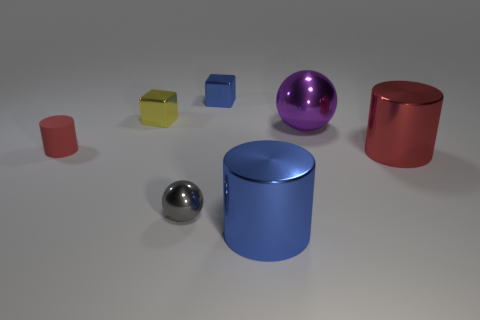Is there anything else that is the same material as the small cylinder?
Keep it short and to the point. No. Are there any small blue matte things that have the same shape as the tiny red thing?
Your response must be concise. No. What is the size of the blue metal object that is left of the big blue cylinder?
Your answer should be compact. Small. There is a yellow object that is the same size as the blue shiny block; what is it made of?
Ensure brevity in your answer.  Metal. Are there more blue matte spheres than blue shiny blocks?
Offer a very short reply. No. How big is the blue object that is on the right side of the small block that is right of the small yellow metallic cube?
Your response must be concise. Large. The purple metal object that is the same size as the blue shiny cylinder is what shape?
Keep it short and to the point. Sphere. There is a small metallic thing in front of the large purple ball that is behind the tiny metallic ball that is in front of the small blue object; what is its shape?
Make the answer very short. Sphere. There is a big cylinder that is on the left side of the big ball; is its color the same as the cube on the right side of the gray metal ball?
Make the answer very short. Yes. How many tiny cyan metal cylinders are there?
Provide a short and direct response. 0. 